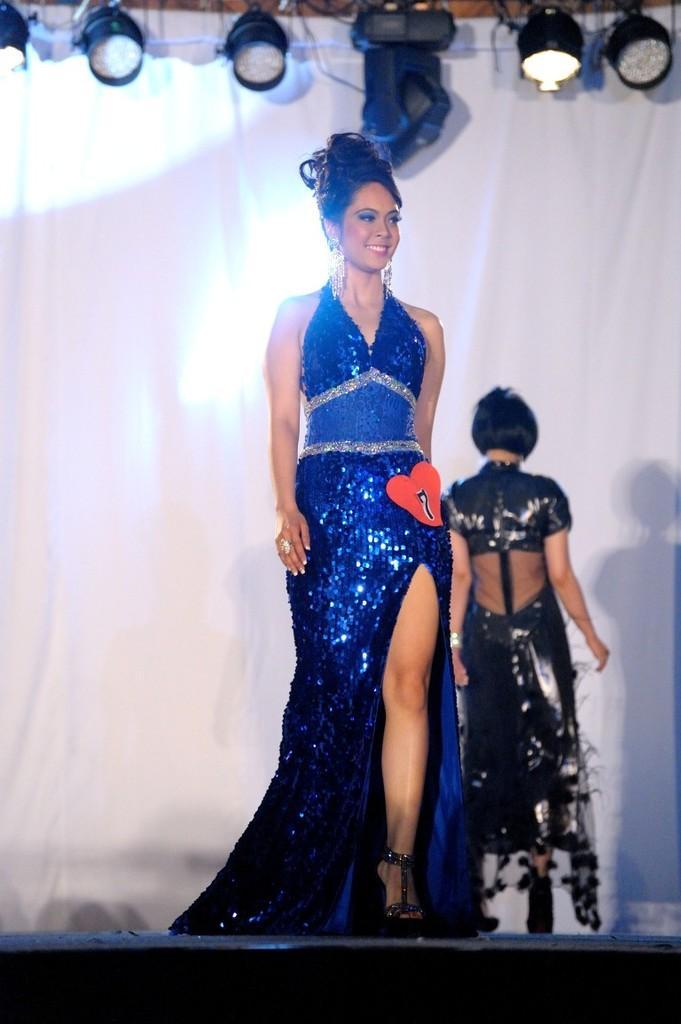Describe this image in one or two sentences. In this image I can see few people are wearing different color dresses. I can see few lights and the white color cloth. 